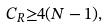Convert formula to latex. <formula><loc_0><loc_0><loc_500><loc_500>C _ { R } { \geq } 4 ( N - 1 ) ,</formula> 